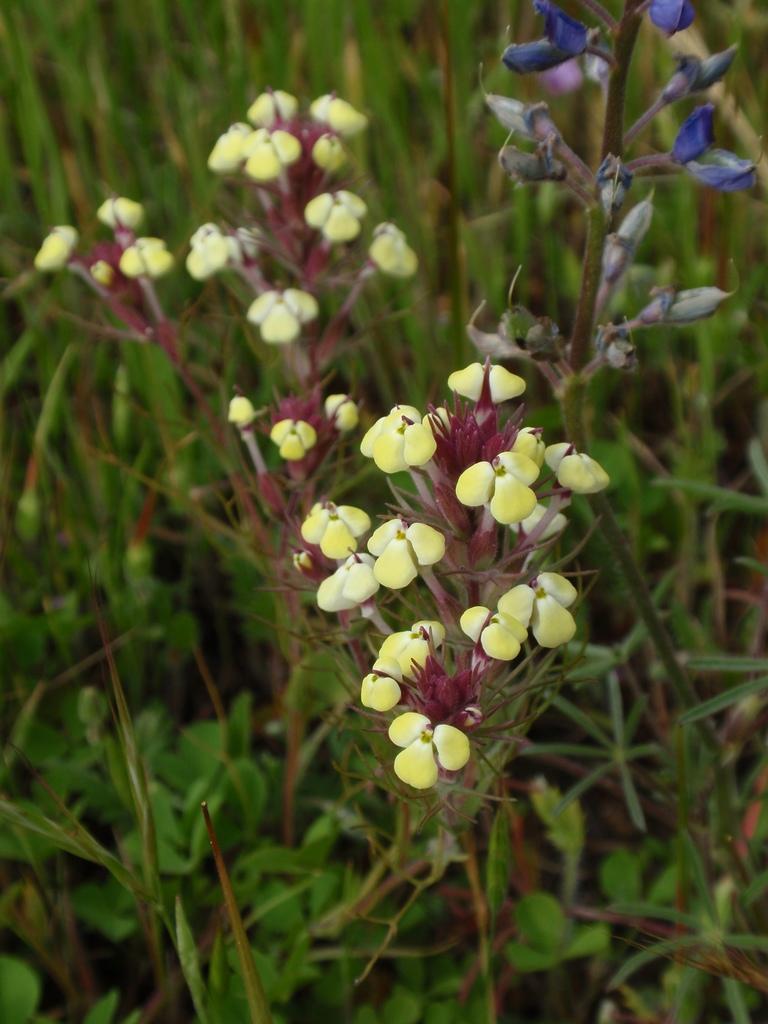Could you give a brief overview of what you see in this image? In this image we can see some plants with flowers and buds. 